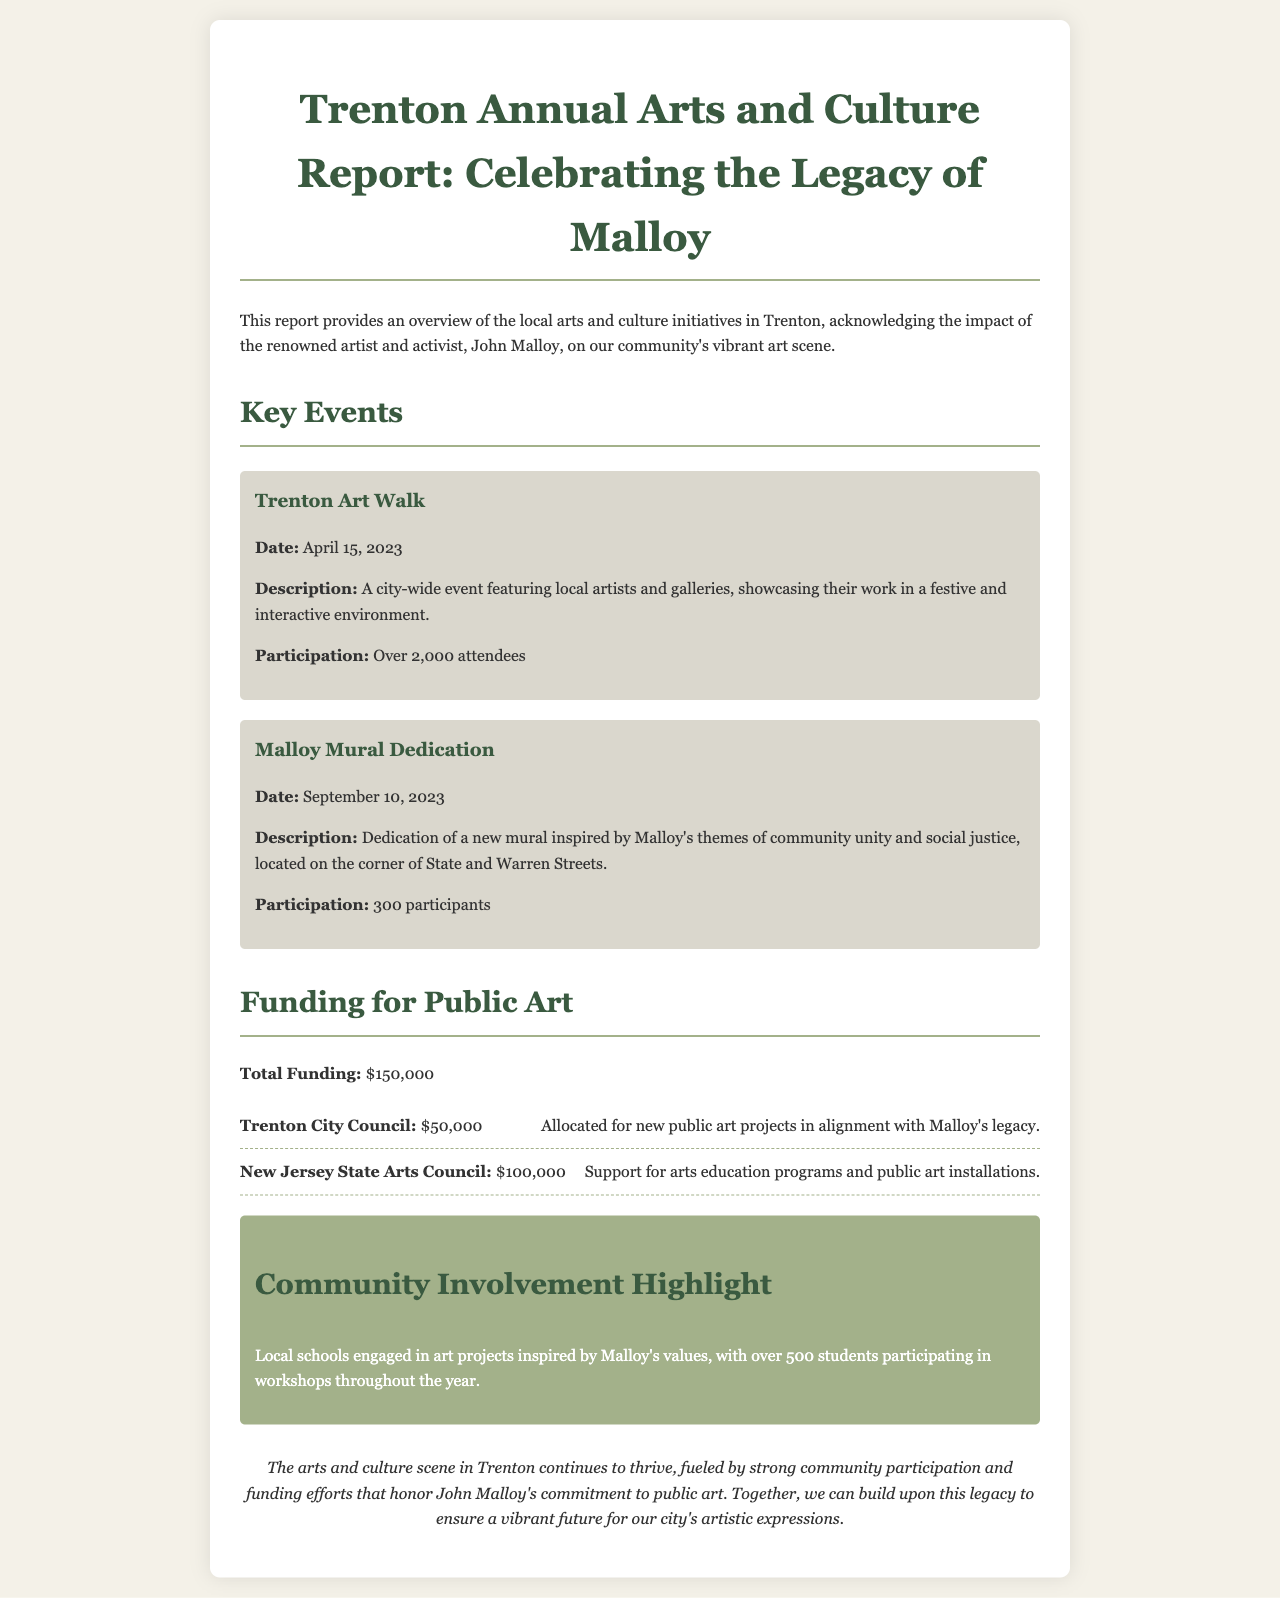What was the total funding for public art? The total funding for public art is clearly stated in the document.
Answer: $150,000 When did the Trenton Art Walk take place? The event's date is listed under the key events section.
Answer: April 15, 2023 How many attendees were at the Trenton Art Walk? The number of attendees for the event is specified in the description.
Answer: Over 2,000 attendees What organization provided $50,000 for public art? The funding source is mentioned in the funding section of the report.
Answer: Trenton City Council How many students participated in workshops inspired by Malloy's values? The report highlights the community involvement and mentions the number of participants.
Answer: Over 500 students What was the purpose of the Malloy Mural Dedication? The description of the event explains its purpose related to Malloy's themes.
Answer: Community unity and social justice Which street is the new mural located on? The location of the mural is explicitly mentioned in the event description.
Answer: Corner of State and Warren Streets What was the participation for the Malloy Mural Dedication? The number of participants is provided in the event details.
Answer: 300 participants What is highlighted in the community involvement section? This section emphasizes the local engagement inspired by Malloy's values.
Answer: Art projects inspired by Malloy's values 